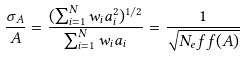Convert formula to latex. <formula><loc_0><loc_0><loc_500><loc_500>\frac { \sigma _ { A } } { A } = \frac { ( \sum _ { i = 1 } ^ { N } w _ { i } a _ { i } ^ { 2 } ) ^ { 1 / 2 } } { \sum _ { i = 1 } ^ { N } w _ { i } a _ { i } } = \frac { 1 } { \sqrt { N _ { e } f f ( A ) } }</formula> 